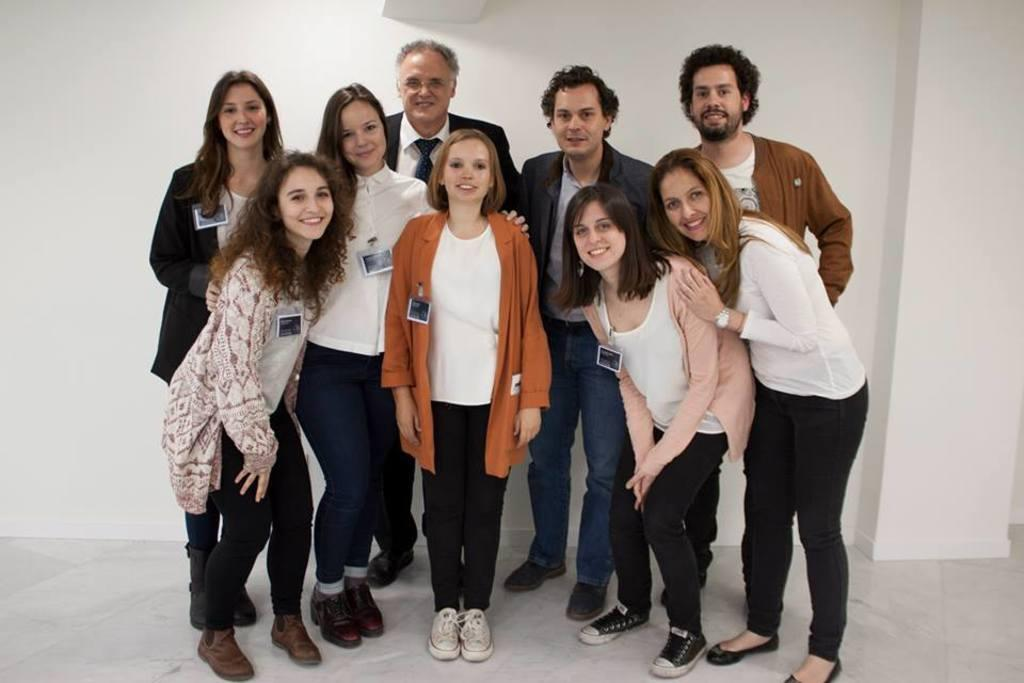Who or what can be seen in the image? There are people in the image. What are the people doing in the image? The people are standing and smiling. What is the surface beneath the people's feet in the image? There is a floor visible in the image. What can be seen behind the people in the image? There is a white wall in the background of the image. What type of vegetable is being held by the person on the left in the image? There is no vegetable visible in the image, as the people are not holding any objects. How many fingers does the person on the right have in the image? We cannot determine the number of fingers the person on the right has in the image, as the image does not provide enough detail to count them. 